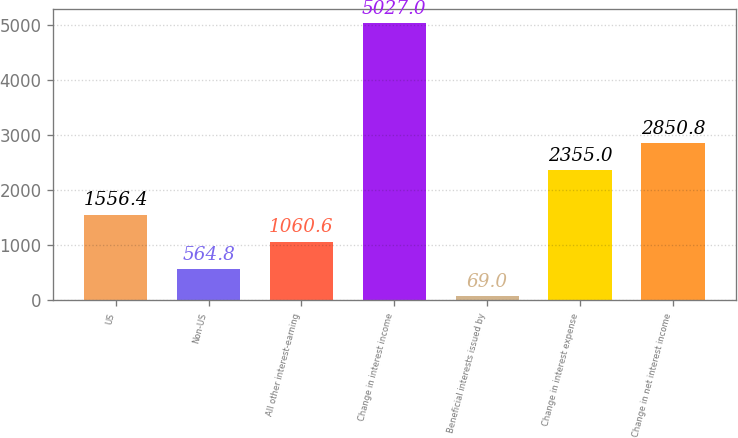Convert chart. <chart><loc_0><loc_0><loc_500><loc_500><bar_chart><fcel>US<fcel>Non-US<fcel>All other interest-earning<fcel>Change in interest income<fcel>Beneficial interests issued by<fcel>Change in interest expense<fcel>Change in net interest income<nl><fcel>1556.4<fcel>564.8<fcel>1060.6<fcel>5027<fcel>69<fcel>2355<fcel>2850.8<nl></chart> 